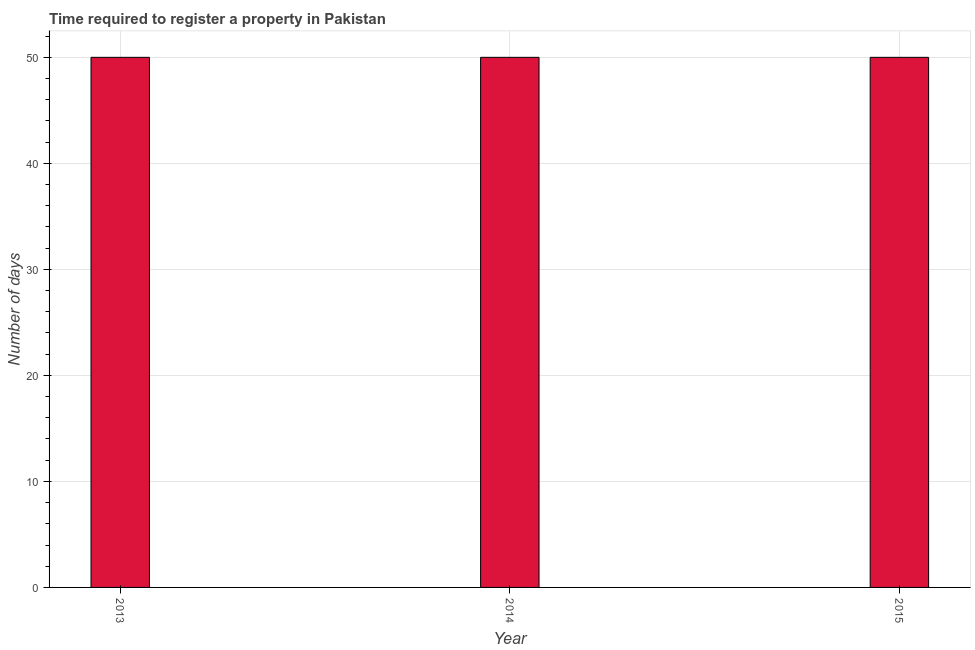Does the graph contain any zero values?
Keep it short and to the point. No. What is the title of the graph?
Make the answer very short. Time required to register a property in Pakistan. What is the label or title of the X-axis?
Make the answer very short. Year. What is the label or title of the Y-axis?
Your answer should be very brief. Number of days. Across all years, what is the minimum number of days required to register property?
Your response must be concise. 50. What is the sum of the number of days required to register property?
Offer a very short reply. 150. What is the difference between the number of days required to register property in 2013 and 2014?
Keep it short and to the point. 0. What is the average number of days required to register property per year?
Offer a very short reply. 50. What is the ratio of the number of days required to register property in 2013 to that in 2014?
Make the answer very short. 1. Are all the bars in the graph horizontal?
Offer a terse response. No. What is the difference between two consecutive major ticks on the Y-axis?
Your answer should be compact. 10. What is the Number of days of 2013?
Provide a succinct answer. 50. What is the Number of days in 2014?
Provide a succinct answer. 50. What is the Number of days in 2015?
Your answer should be very brief. 50. What is the difference between the Number of days in 2014 and 2015?
Keep it short and to the point. 0. What is the ratio of the Number of days in 2013 to that in 2014?
Keep it short and to the point. 1. 